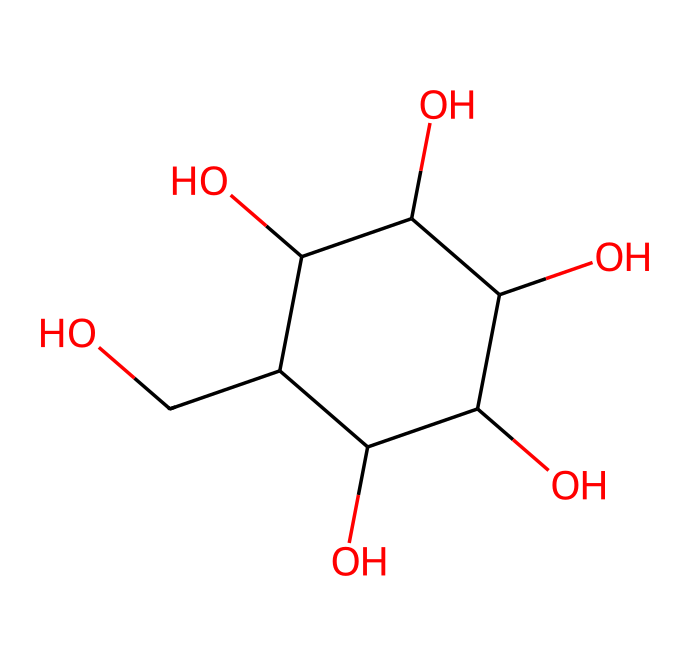What is the molecular formula of glucose? By examining the SMILES representation, we can identify the number of carbon (C), hydrogen (H), and oxygen (O) atoms. The molecule contains 6 carbon atoms, 12 hydrogen atoms, and 6 oxygen atoms. Therefore, the molecular formula is C6H12O6.
Answer: C6H12O6 How many carbon atoms are present in this structure? The SMILES notation indicates that there are 6 occurrences of the carbon atom represented by "C." Counting these, we find that there are 6 carbon atoms.
Answer: 6 How many hydroxyl (-OH) groups are there in this molecule? By analyzing the structure, we can identify each hydroxyl group (where an oxygen is bonded to a hydrogen). The SMILES shows 5 occurrences of -OH, indicating there are 5 hydroxyl groups present.
Answer: 5 Is glucose a type of polysaccharide? Glucose is a simple sugar or monosaccharide; it is not a polysaccharide, which is made up of multiple sugar units. Thus, glucose is the building block of polysaccharides.
Answer: no What feature of glucose contributes to its solubility in water? The presence of multiple hydroxyl (-OH) groups in the structure of glucose creates strong hydrogen bonding with water molecules, contributing to its high solubility.
Answer: hydroxyl groups What is the main functional group in glucose? The main functional group can be identified by the presence of multiple hydroxyl (-OH) groups in the structure, which are characteristic of alcohols. Hence, the primary functional group is the hydroxyl group.
Answer: hydroxyl group 